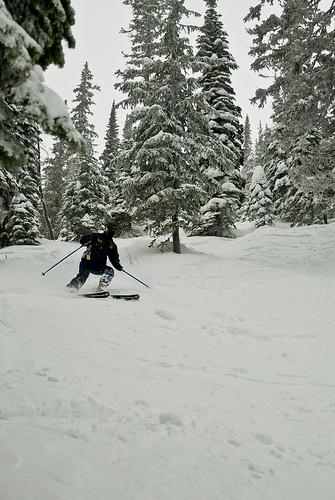Provide a snapshot of the primary subject in the image and their current activity. The primary subject is a male skier wearing a black jacket and ski mask, skiing downhill and utilizing blue ski poles. Mention the primary object in the photograph and their current activity. A person wearing a black jacket and black ski mask is skiing down a snow-covered slope holding blue ski poles. Concisely describe the image's central figure and the action occurring. The image shows a man adorned in black ski gear, skiing down a snow-filled slope while holding onto his blue ski poles. Briefly describe the main focus of the image and the action taking place. The image focuses on a man in a black ski jacket and goggles skiing down a slope with blue poles in his hands. Summarize the main subject and their action in the scene. A man clad in black ski attire is skiing down a snowy slope, gripping blue ski poles. Briefly characterize the main individual in the photo and their present action. The photo features a man in black skiing attire, skiing down a snowy incline while grasping blue ski poles. Explain what the central character in the picture is engaged in. The central character, a man in a black ski outfit and goggles, is engaged in skiing down a snow-laden slope with blue ski poles in hand. Describe the leading subject in the picture and their engagement in the scene. The leading subject is a male skier wearing a black outfit and goggles, skiing down a snow-covered slope with his blue ski poles in hand. Outline the main persona in the photo and specify what they are doing. In the photo, a man dressed in black ski gear and goggles is skiing down a snowy terrain while holding onto blue ski poles. Identify the principal figure in the image and describe their ongoing action. A skier dressed in black and wearing goggles is seen descending a snowy hill while holding blue ski poles. 